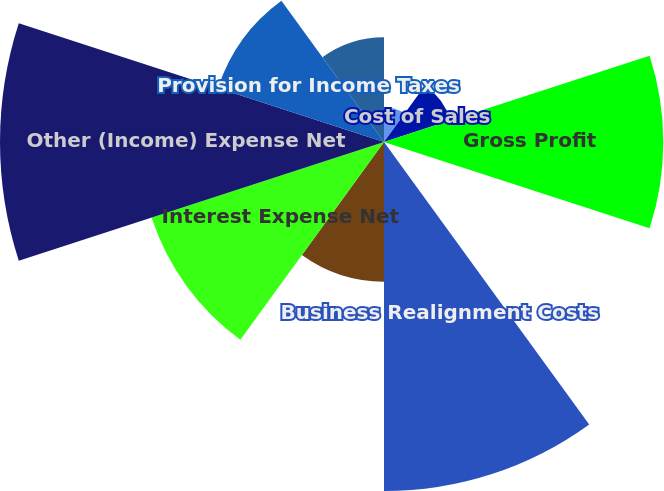Convert chart to OTSL. <chart><loc_0><loc_0><loc_500><loc_500><pie_chart><fcel>Net Sales<fcel>Cost of Sales<fcel>Gross Profit<fcel>SM&A Expense<fcel>Business Realignment Costs<fcel>Operating Profit<fcel>Interest Expense Net<fcel>Other (Income) Expense Net<fcel>Provision for Income Taxes<fcel>Net Income Including<nl><fcel>1.97%<fcel>3.93%<fcel>15.68%<fcel>0.01%<fcel>19.6%<fcel>7.84%<fcel>13.72%<fcel>21.56%<fcel>9.8%<fcel>5.88%<nl></chart> 